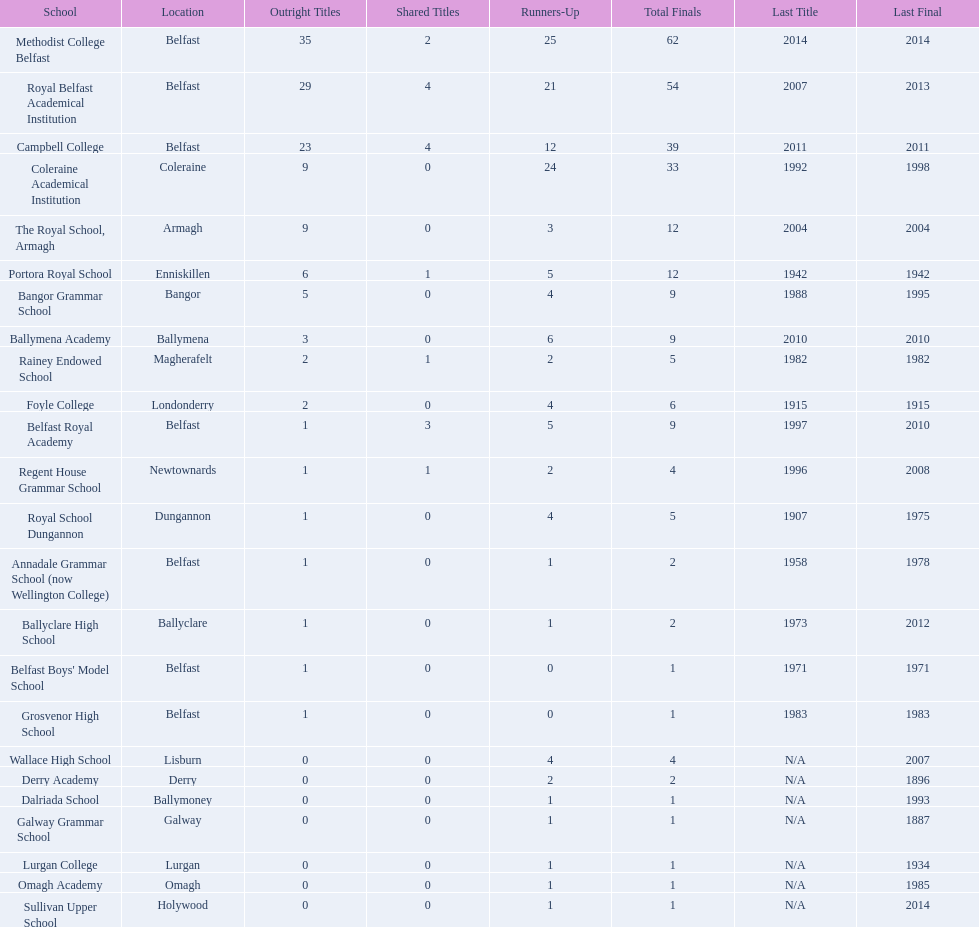Which two schools each had twelve total finals? The Royal School, Armagh, Portora Royal School. 